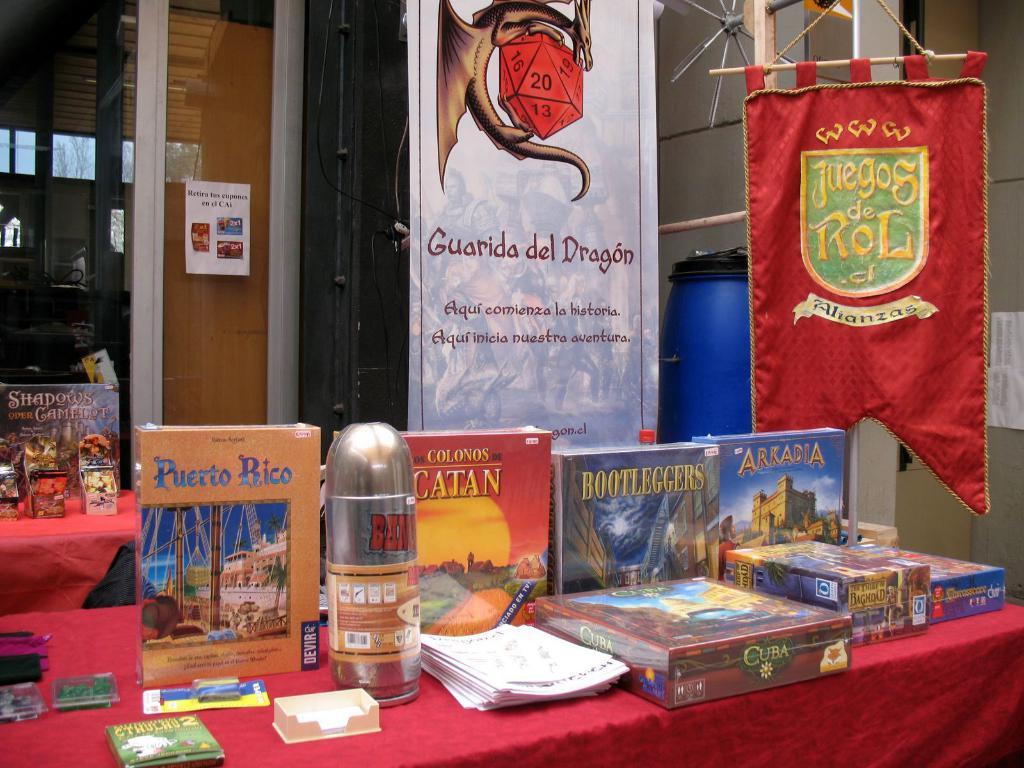What is the book 2nd from the left called?
Make the answer very short. Puerto rico. What state is on the orange book?
Offer a very short reply. Puerto rico. 